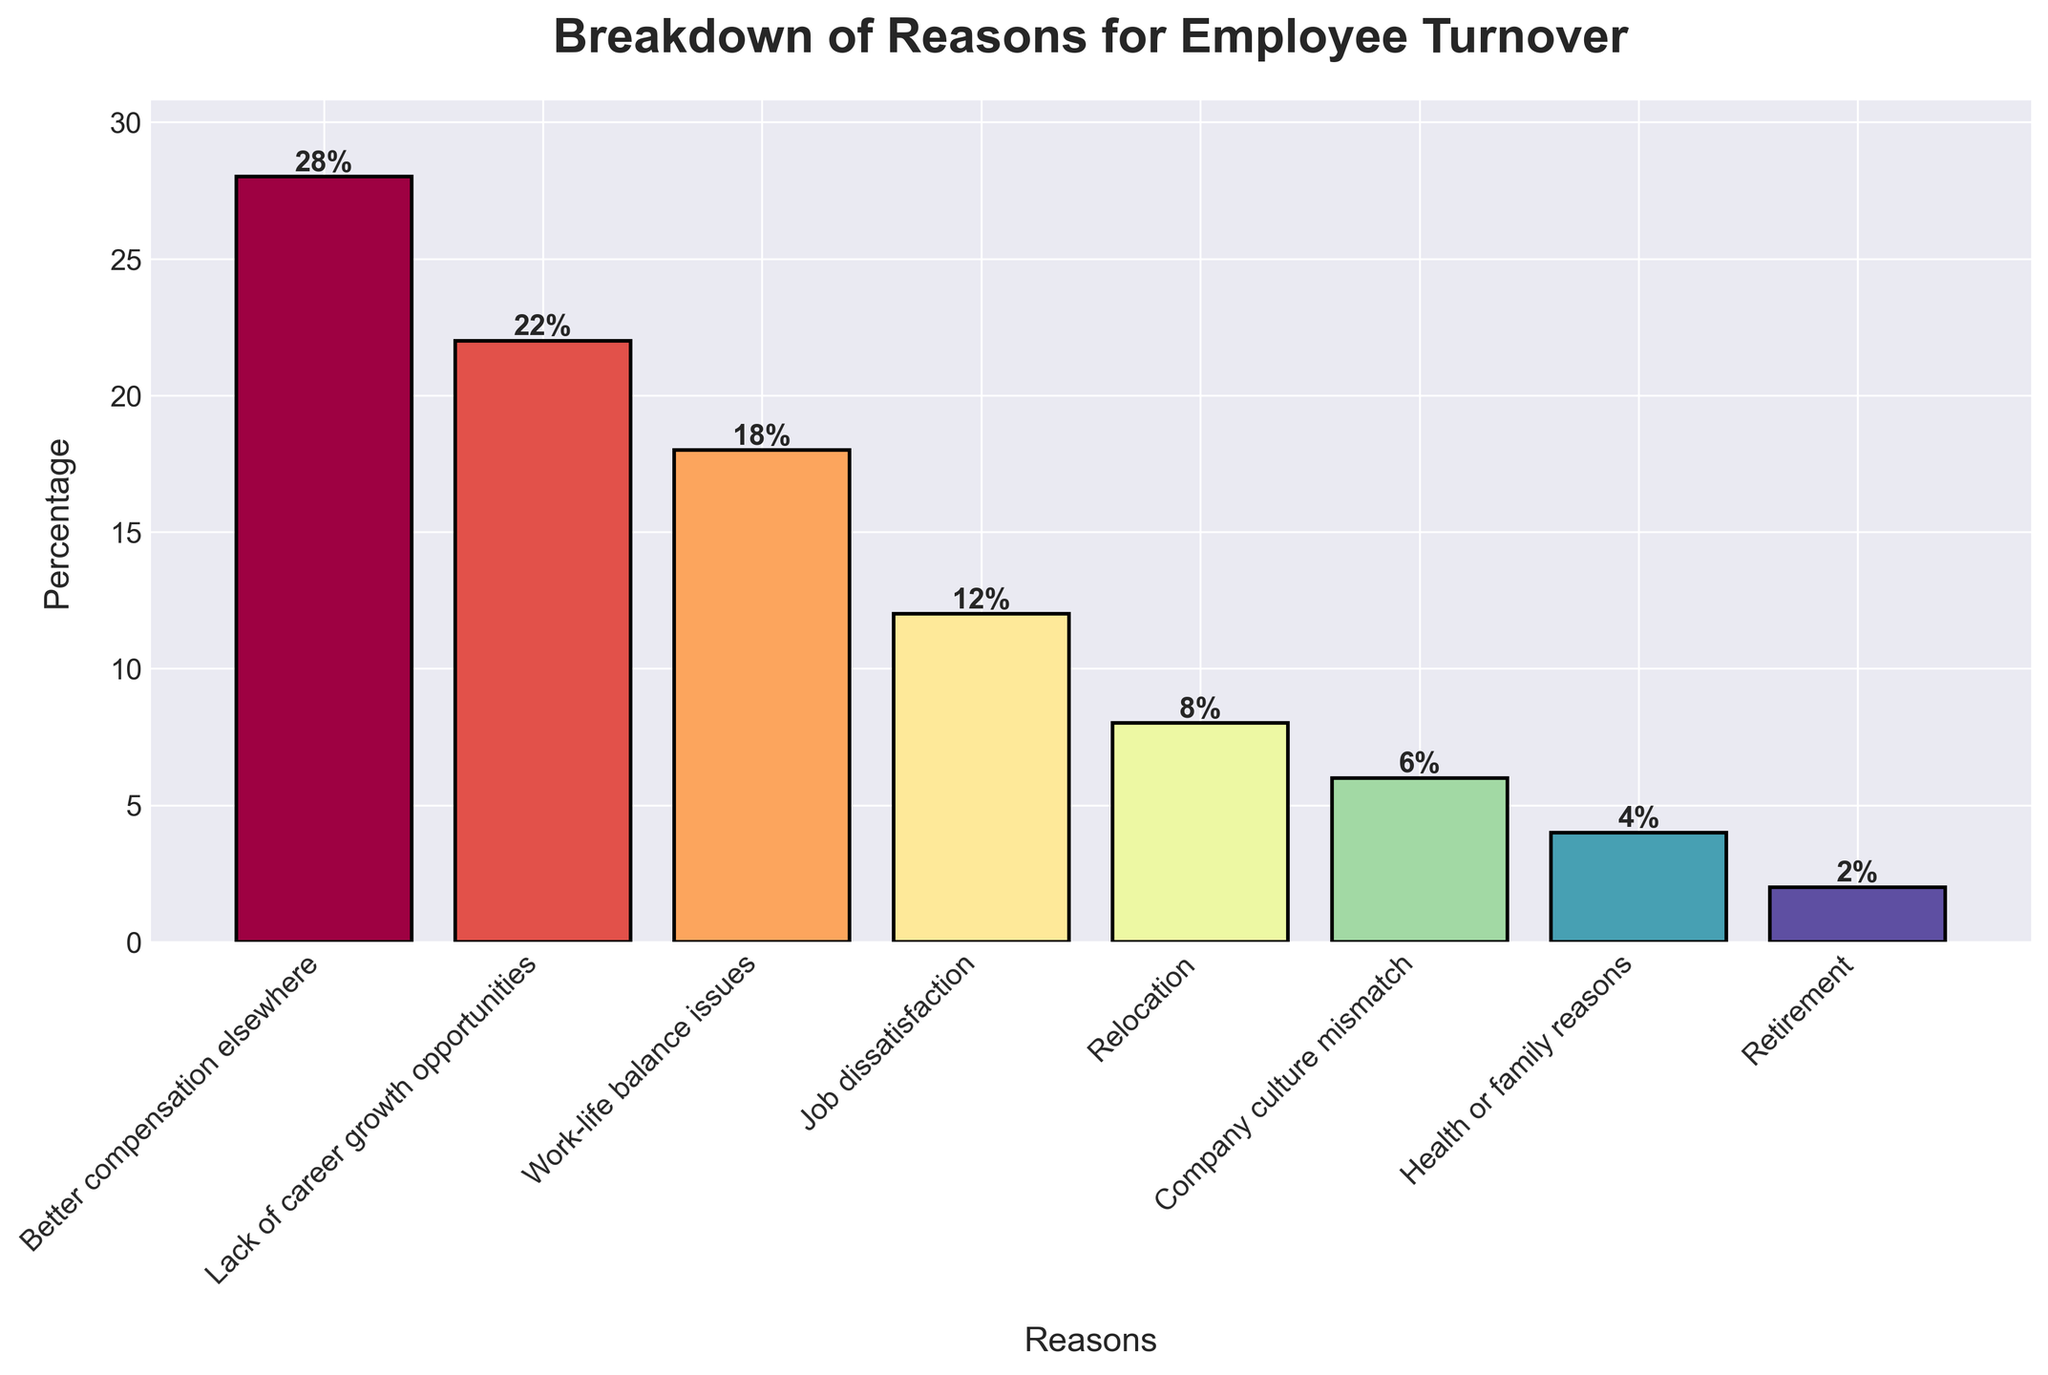Which reason has the highest percentage of employee turnover? The highest bar on the chart represents the reason with the highest percentage. The "Better compensation elsewhere" bar is the tallest.
Answer: Better compensation elsewhere How much higher is the percentage of turnover due to better compensation compared to job dissatisfaction? The percentage for "Better compensation elsewhere" is 28%, and "Job dissatisfaction" is 12%. The difference is 28% - 12% = 16%.
Answer: 16% What is the combined percentage of turnover due to health or family reasons and retirement? Add the percentages for "Health or family reasons" and "Retirement": 4% + 2% = 6%.
Answer: 6% Which two reasons have the closest percentages of employee turnover? Look at the bars that have almost the same height. "Job dissatisfaction" at 12% and "Relocation" at 8% are the closest, with a difference of 4%.
Answer: Job dissatisfaction and Relocation Which reason has the lowest percentage of employee turnover? The shortest bar on the chart represents the reason with the lowest percentage. "Retirement" is the shortest.
Answer: Retirement Is the percentage of turnover due to work-life balance issues greater than or less than the combined percentage of turnover due to company culture mismatch and relocation? The percentage for "Work-life balance issues" is 18%. The combined percentage for "Company culture mismatch" and "Relocation" is 6% + 8% = 14%. 18% is greater than 14%.
Answer: Greater What is the total percentage of employee turnover for reasons other than better compensation or lack of career growth opportunities? Add the percentages for reasons other than the top two: 18% (Work-life balance issues) + 12% (Job dissatisfaction) + 8% (Relocation) + 6% (Company culture mismatch) + 4% (Health or family reasons) + 2% (Retirement) = 50%.
Answer: 50% How much lower is the percentage of turnover due to relocation compared to lack of career growth opportunities? The percentage for "Relocation" is 8%, and for "Lack of career growth opportunities" is 22%. The difference is 22% - 8% = 14%.
Answer: 14% What is the average percentage of turnover for company culture mismatch, health or family reasons, and retirement? Add the percentages for these three reasons and divide by 3: (6% + 4% + 2%)/3 = 12%/3 = 4%.
Answer: 4% Which reasons have a turnover percentage of less than 10%? Each bar that is less than 10% corresponds to reasons with turnover percentages below 10%. These are "Relocation" (8%), "Company culture mismatch" (6%), "Health or family reasons" (4%), and "Retirement" (2%).
Answer: Relocation, Company culture mismatch, Health or family reasons, Retirement 